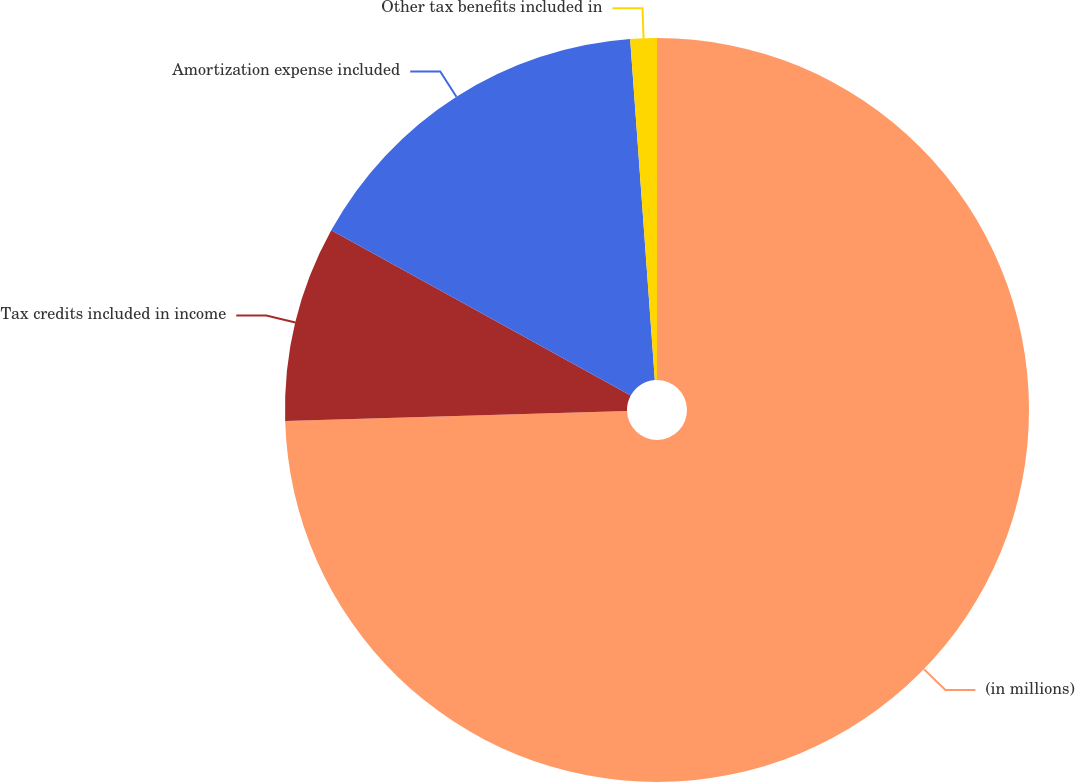<chart> <loc_0><loc_0><loc_500><loc_500><pie_chart><fcel>(in millions)<fcel>Tax credits included in income<fcel>Amortization expense included<fcel>Other tax benefits included in<nl><fcel>74.54%<fcel>8.49%<fcel>15.83%<fcel>1.15%<nl></chart> 